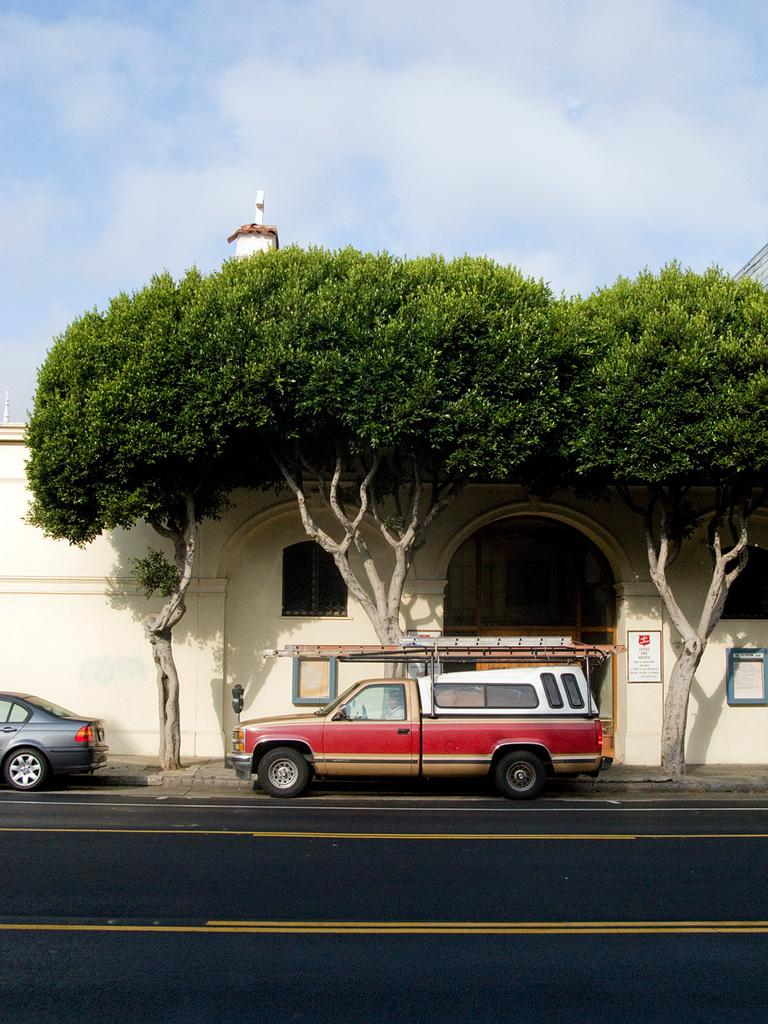What is the main feature of the image? There is a road in the image. What else can be seen on the road? There are vehicles in the image. What can be seen in the background of the image? There are trees, at least one building, windows, and the sky visible in the background of the image. What type of corn can be seen rolling down the road in the image? There is no corn present in the image, and therefore no such activity can be observed. 